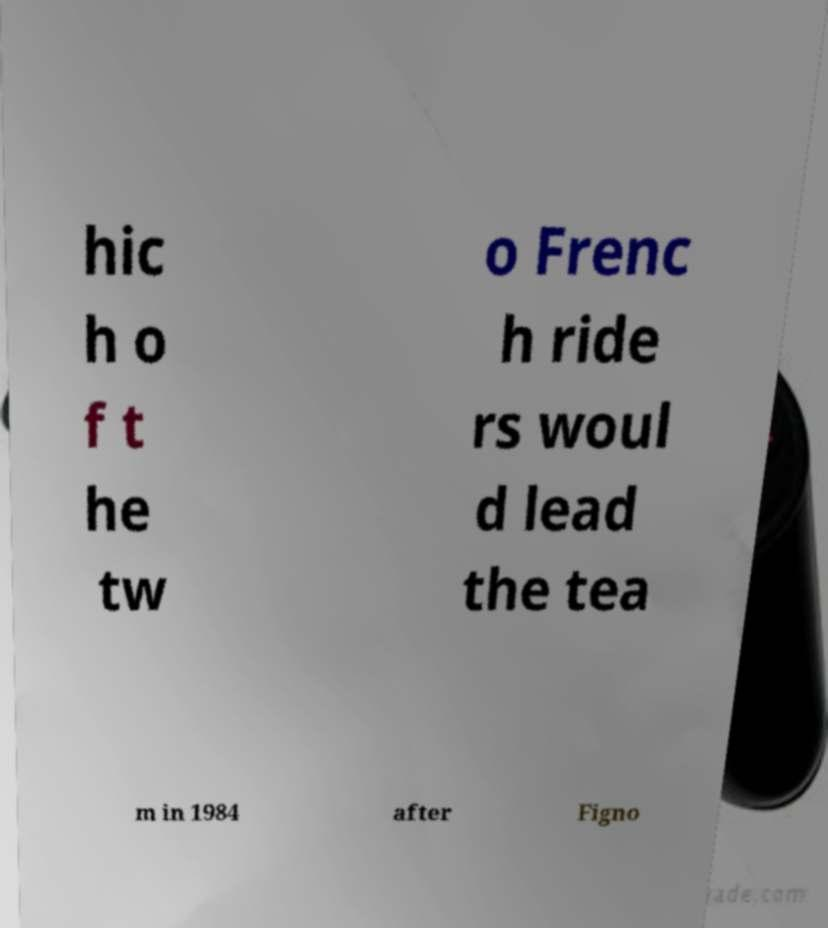Please read and relay the text visible in this image. What does it say? hic h o f t he tw o Frenc h ride rs woul d lead the tea m in 1984 after Figno 